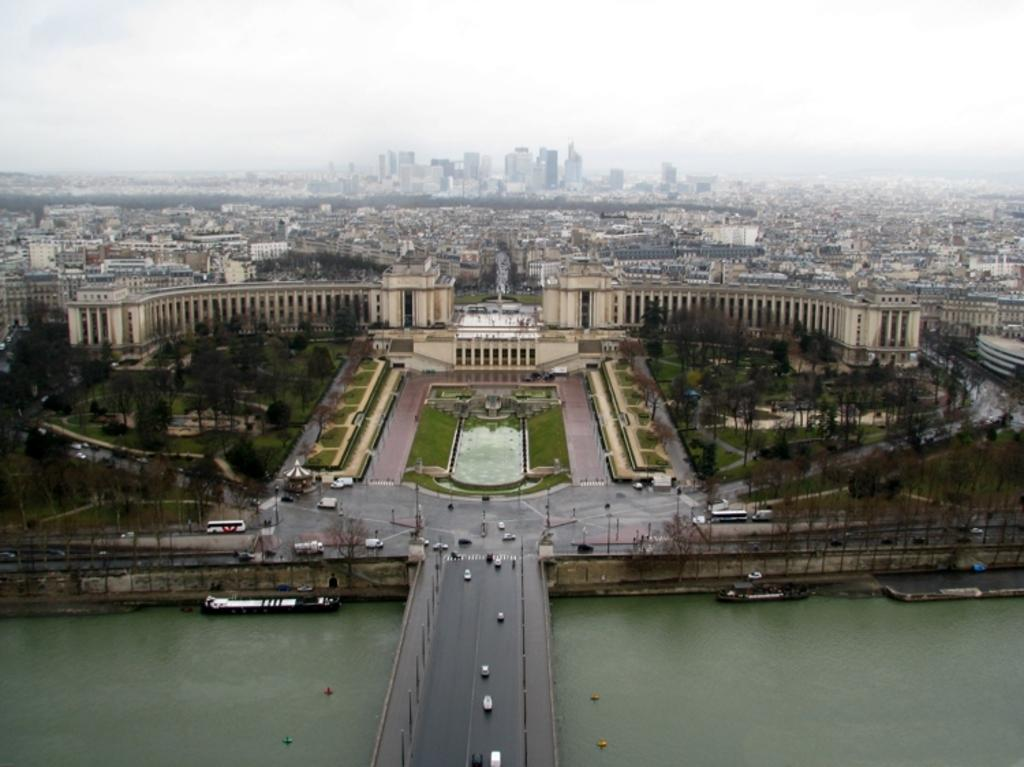What structure can be seen crossing over the water in the image? There is a bridge in the image. What type of natural feature is visible in the image? There is water visible in the image. What type of man-made structure can be seen in the image? There is a building in the image. What is visible at the top of the image? The sky is visible at the top of the image. What is the size of the lake in the image? There is no lake present in the image. How does the digestion process work for the bridge in the image? The bridge in the image does not have a digestion process, as it is a man-made structure and not a living organism. 